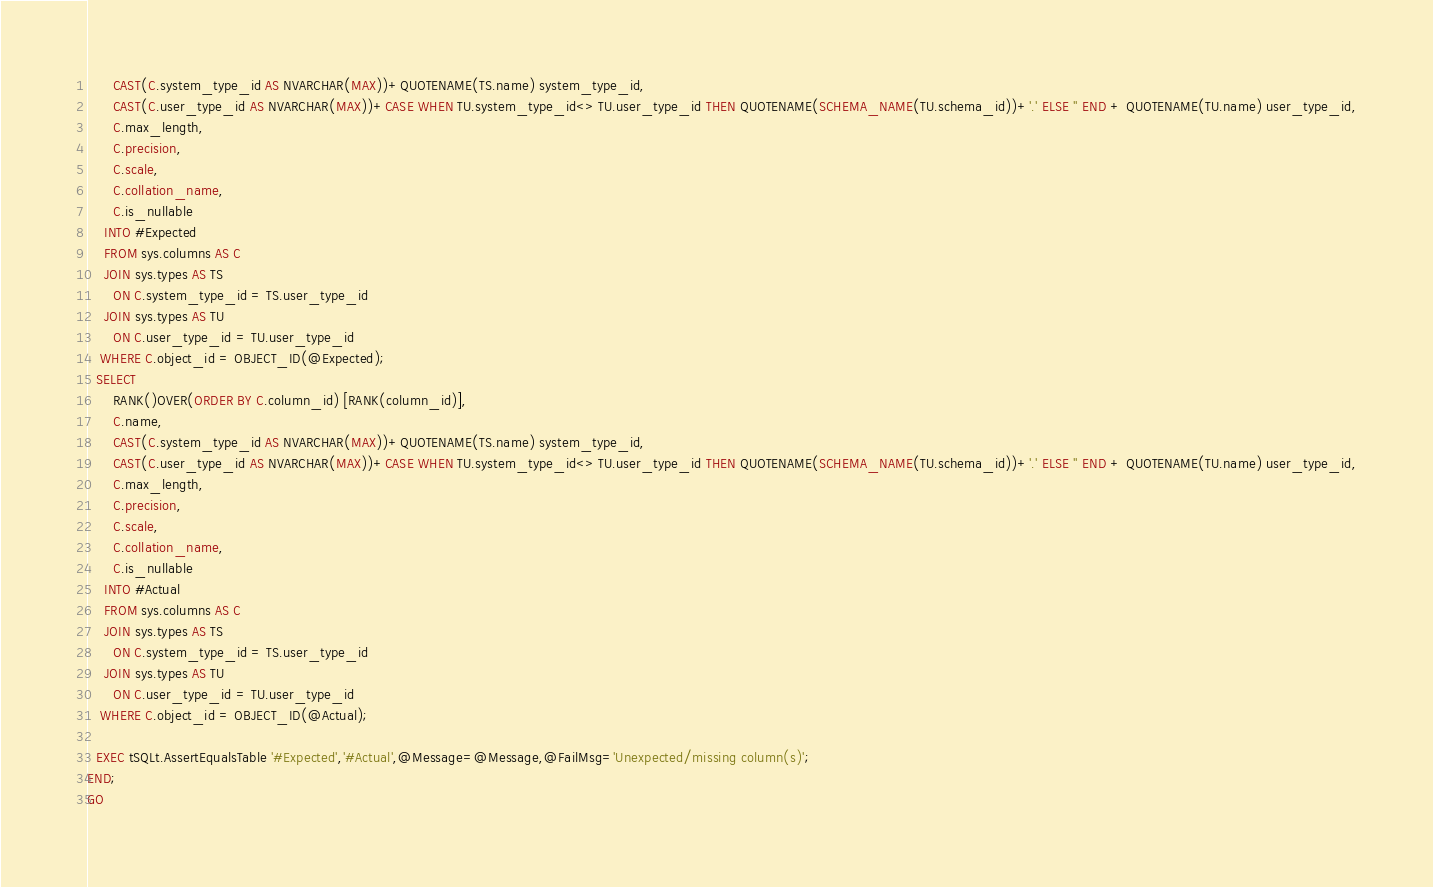Convert code to text. <code><loc_0><loc_0><loc_500><loc_500><_SQL_>      CAST(C.system_type_id AS NVARCHAR(MAX))+QUOTENAME(TS.name) system_type_id,
      CAST(C.user_type_id AS NVARCHAR(MAX))+CASE WHEN TU.system_type_id<> TU.user_type_id THEN QUOTENAME(SCHEMA_NAME(TU.schema_id))+'.' ELSE '' END + QUOTENAME(TU.name) user_type_id,
      C.max_length,
      C.precision,
      C.scale,
      C.collation_name,
      C.is_nullable
    INTO #Expected
    FROM sys.columns AS C
    JOIN sys.types AS TS
      ON C.system_type_id = TS.user_type_id
    JOIN sys.types AS TU
      ON C.user_type_id = TU.user_type_id
   WHERE C.object_id = OBJECT_ID(@Expected);
  SELECT 
      RANK()OVER(ORDER BY C.column_id) [RANK(column_id)],
      C.name,
      CAST(C.system_type_id AS NVARCHAR(MAX))+QUOTENAME(TS.name) system_type_id,
      CAST(C.user_type_id AS NVARCHAR(MAX))+CASE WHEN TU.system_type_id<> TU.user_type_id THEN QUOTENAME(SCHEMA_NAME(TU.schema_id))+'.' ELSE '' END + QUOTENAME(TU.name) user_type_id,
      C.max_length,
      C.precision,
      C.scale,
      C.collation_name,
      C.is_nullable
    INTO #Actual
    FROM sys.columns AS C
    JOIN sys.types AS TS
      ON C.system_type_id = TS.user_type_id
    JOIN sys.types AS TU
      ON C.user_type_id = TU.user_type_id
   WHERE C.object_id = OBJECT_ID(@Actual);
  
  EXEC tSQLt.AssertEqualsTable '#Expected','#Actual',@Message=@Message,@FailMsg='Unexpected/missing column(s)';  
END;
GO</code> 